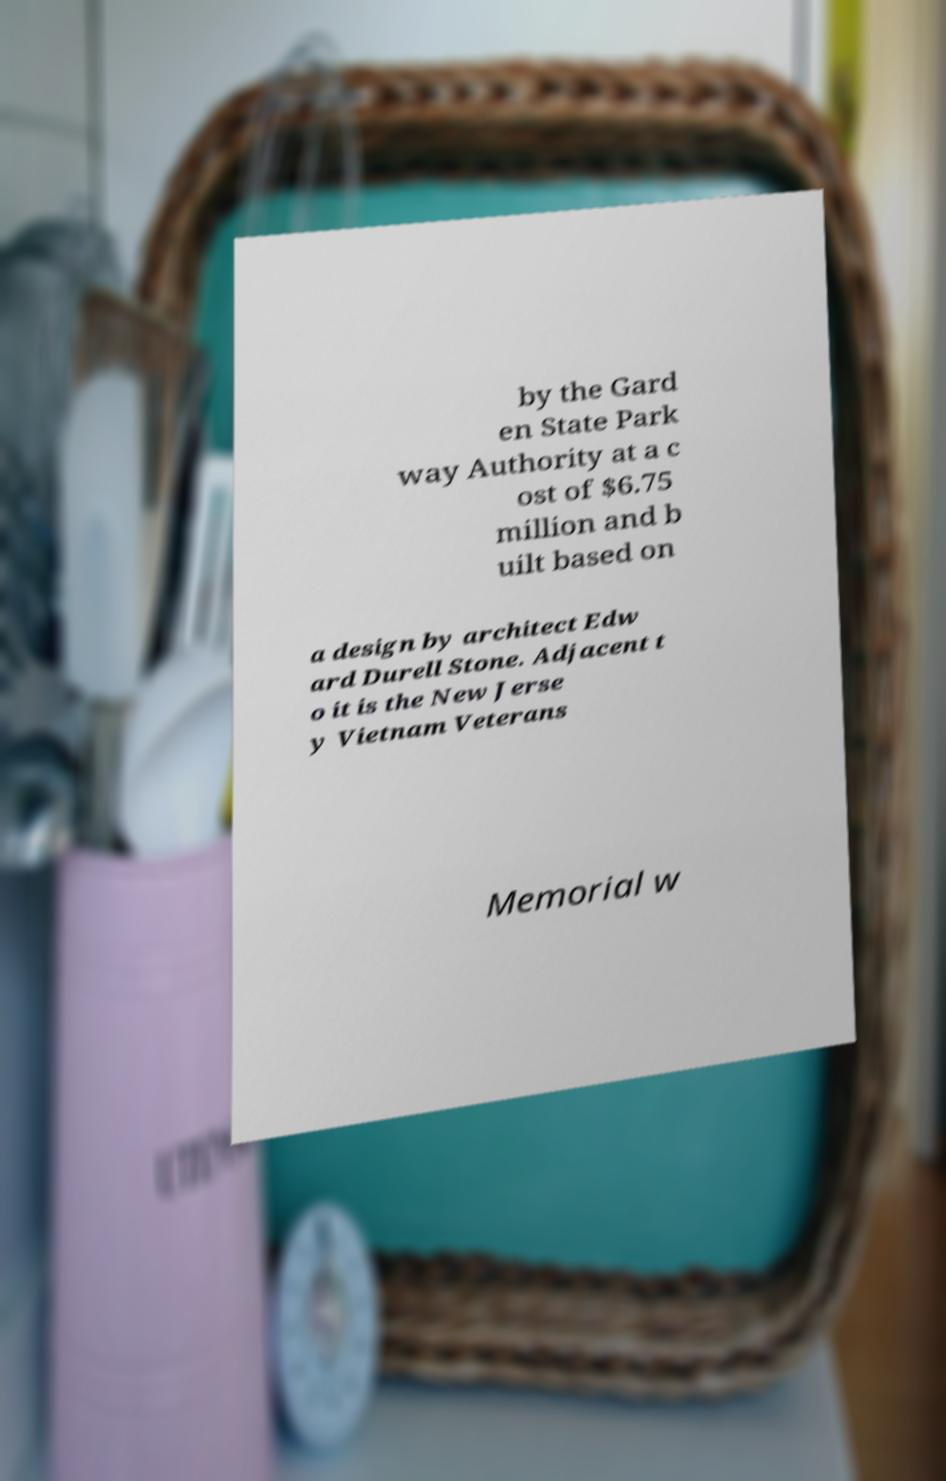I need the written content from this picture converted into text. Can you do that? by the Gard en State Park way Authority at a c ost of $6.75 million and b uilt based on a design by architect Edw ard Durell Stone. Adjacent t o it is the New Jerse y Vietnam Veterans Memorial w 